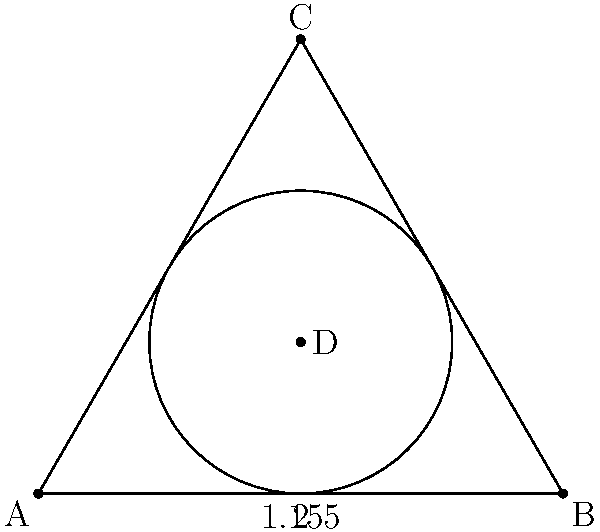In a pub hosting a dart tournament, the owner wants to optimize seating arrangements using geometric shapes. They decide to use a triangular table with an inscribed circular area for dart players. If the triangular table has a base of 4 meters and a height of 3.464 meters, what is the maximum number of dart players that can be seated around the circular area if each player requires 1 meter of space? Let's approach this step-by-step:

1) First, we need to find the radius of the inscribed circle. In an equilateral triangle, the radius (r) of the inscribed circle is given by:

   $r = \frac{a}{2\sqrt{3}}$

   where $a$ is the side length of the triangle.

2) We're given the height of the triangle (3.464 m), which in an equilateral triangle is:

   $h = \frac{a\sqrt{3}}{2} = 3.464$

3) Solving for $a$:

   $a = \frac{2h}{\sqrt{3}} = \frac{2(3.464)}{\sqrt{3}} = 4$ meters

4) Now we can calculate the radius:

   $r = \frac{4}{2\sqrt{3}} = \frac{2}{\sqrt{3}} \approx 1.155$ meters

5) The circumference of this circle will be:

   $C = 2\pi r = 2\pi(1.155) \approx 7.257$ meters

6) If each player requires 1 meter of space, we can divide the circumference by 1 to get the maximum number of players:

   $7.257 \div 1 \approx 7.257$

7) Since we can't have a fractional number of players, we round down to the nearest whole number.
Answer: 7 players 